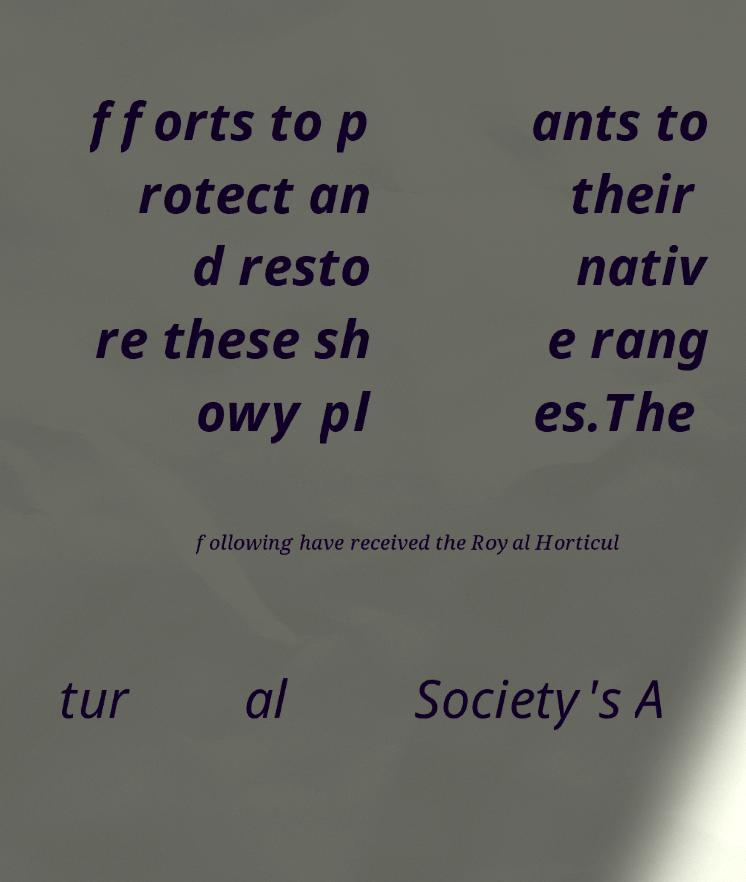For documentation purposes, I need the text within this image transcribed. Could you provide that? fforts to p rotect an d resto re these sh owy pl ants to their nativ e rang es.The following have received the Royal Horticul tur al Society's A 